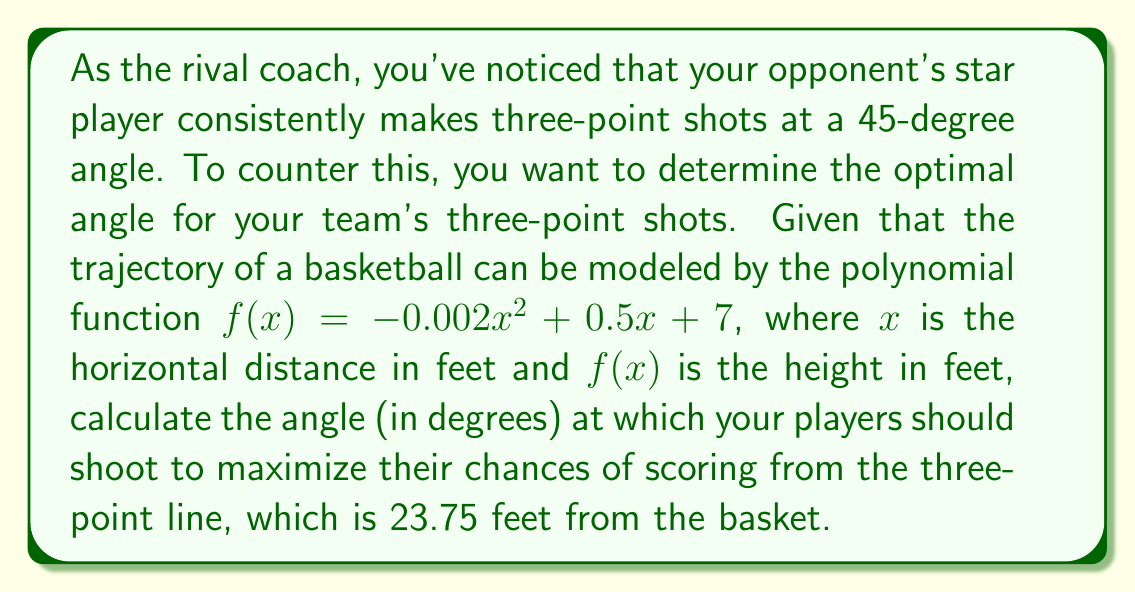Provide a solution to this math problem. To find the optimal angle for the three-point shot, we need to follow these steps:

1) The derivative of the function gives us the slope at any point:
   $f'(x) = -0.004x + 0.5$

2) At the three-point line, $x = 23.75$ feet. Calculate the slope at this point:
   $f'(23.75) = -0.004(23.75) + 0.5 = -0.095 + 0.5 = 0.405$

3) The slope at this point represents the tangent of the angle we're looking for:
   $\tan(\theta) = 0.405$

4) To find the angle, we need to use the inverse tangent function:
   $\theta = \arctan(0.405)$

5) Convert this angle from radians to degrees:
   $\theta = \arctan(0.405) \cdot \frac{180}{\pi} \approx 22.03°$

Therefore, the optimal angle for the three-point shot is approximately 22.03 degrees.
Answer: $22.03°$ 